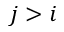Convert formula to latex. <formula><loc_0><loc_0><loc_500><loc_500>j > i</formula> 